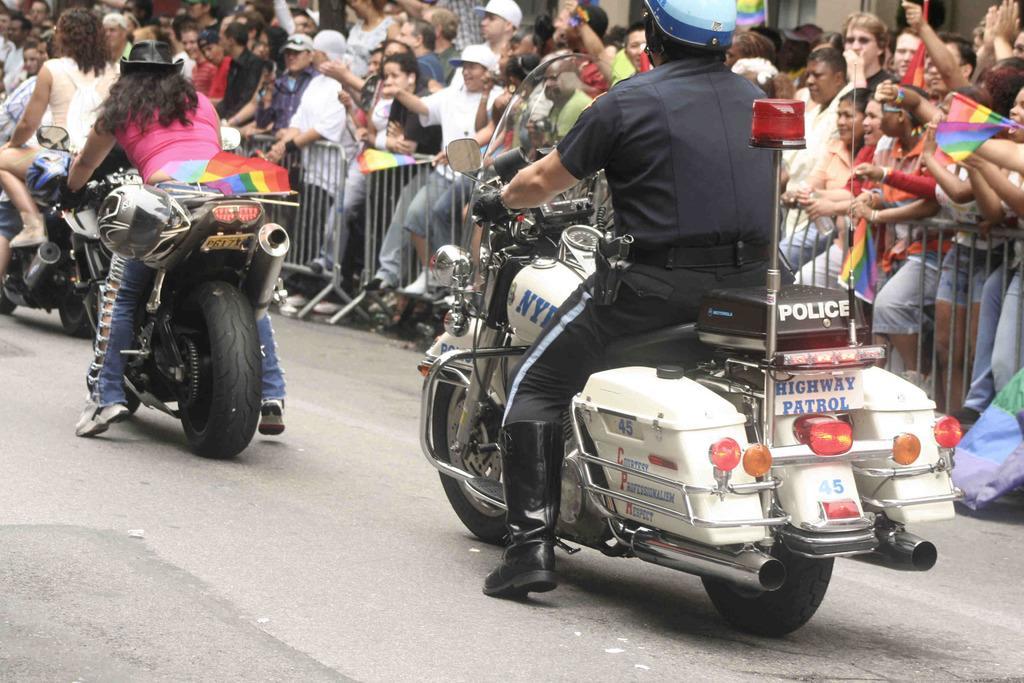What are the people in the image doing? There are people riding motorcycles in the image. What can be seen in the background of the image? There is a group of people cheering in the background, and there are barrel gates in the background. What protective gear is one of the men wearing? One man is wearing a helmet. What type of footwear is another man wearing? One man is wearing shoes. What color is the sky in the image? The provided facts do not mention the color of the sky in the image. However, there is no indication of the sky being visible in the image. How many pins are visible on the motorcycle riders in the image? There are no pins visible on the motorcycle riders in the image. 